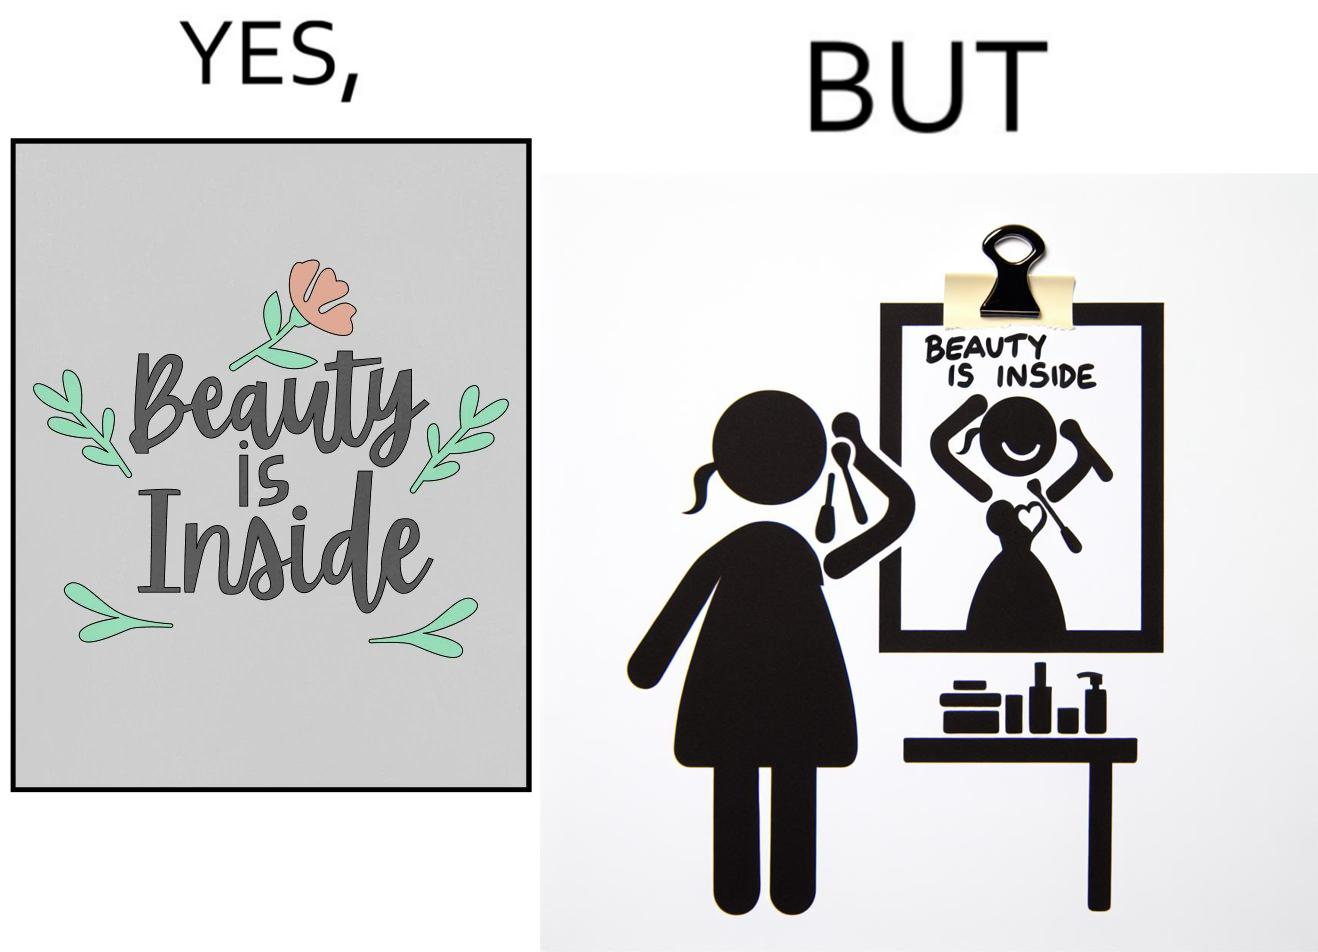Describe the satirical element in this image. The image is satirical because while the text on the paper says that beauty lies inside, the woman ignores the note and continues to apply makeup to improve her outer beauty. 